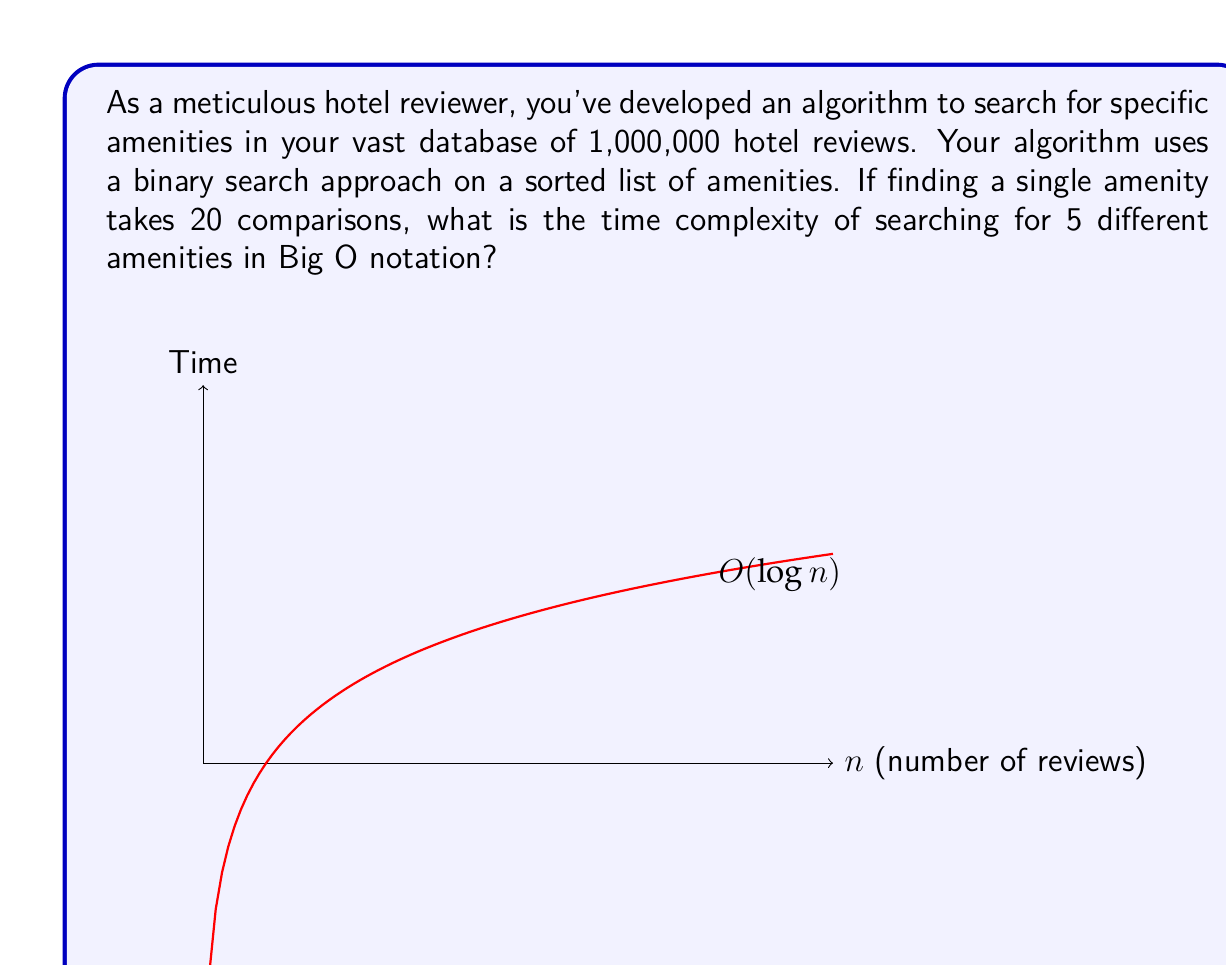Teach me how to tackle this problem. Let's approach this step-by-step:

1) First, we need to understand the time complexity of a single binary search:
   - For a binary search on $n$ elements, the time complexity is $O(\log_2 n)$
   - In this case, $n = 1,000,000$

2) We're told that finding a single amenity takes 20 comparisons. This aligns with the binary search complexity because:
   $$\log_2 1,000,000 \approx 19.93 \approx 20$$

3) Now, we need to consider searching for 5 different amenities:
   - Each search is independent and takes $O(\log_2 n)$ time
   - We perform this search 5 times

4) In Big O notation, when we perform an operation a constant number of times, we don't include that constant in the notation. So even though we're doing the search 5 times, the time complexity remains $O(\log_2 n)$

5) This is because Big O notation describes the upper bound of the growth rate of the function, and multiplying by a constant (in this case, 5) doesn't change the growth rate in the limit as $n$ approaches infinity.

Therefore, the time complexity of searching for 5 different amenities using this algorithm is $O(\log_2 n)$ or simply $O(\log n)$ in Big O notation.
Answer: $O(\log n)$ 